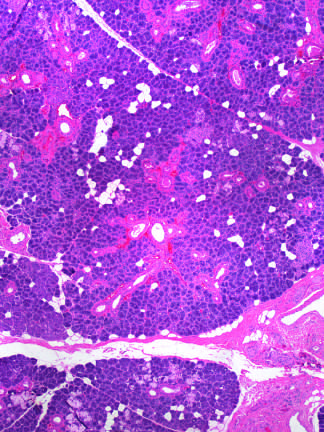how is vascular changes and fibrosis of salivary glands produced?
Answer the question using a single word or phrase. By radiation therapy of the neck region 